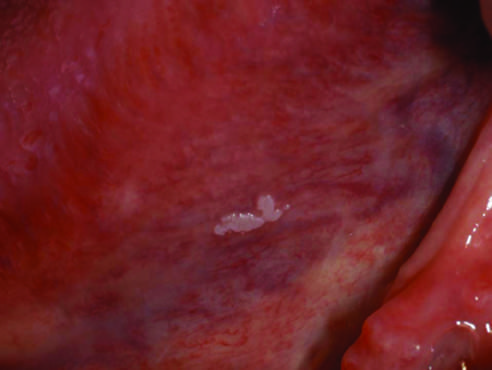how is the lesion in this example?
Answer the question using a single word or phrase. Smooth with well-demarcated borders and minimal elevation 